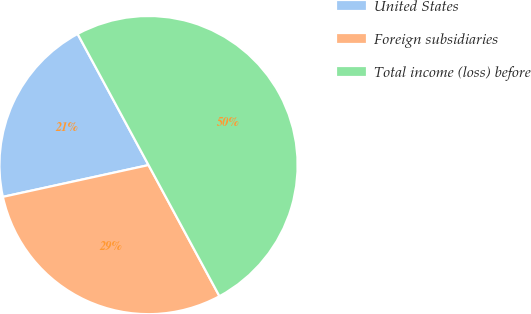<chart> <loc_0><loc_0><loc_500><loc_500><pie_chart><fcel>United States<fcel>Foreign subsidiaries<fcel>Total income (loss) before<nl><fcel>20.53%<fcel>29.47%<fcel>50.0%<nl></chart> 